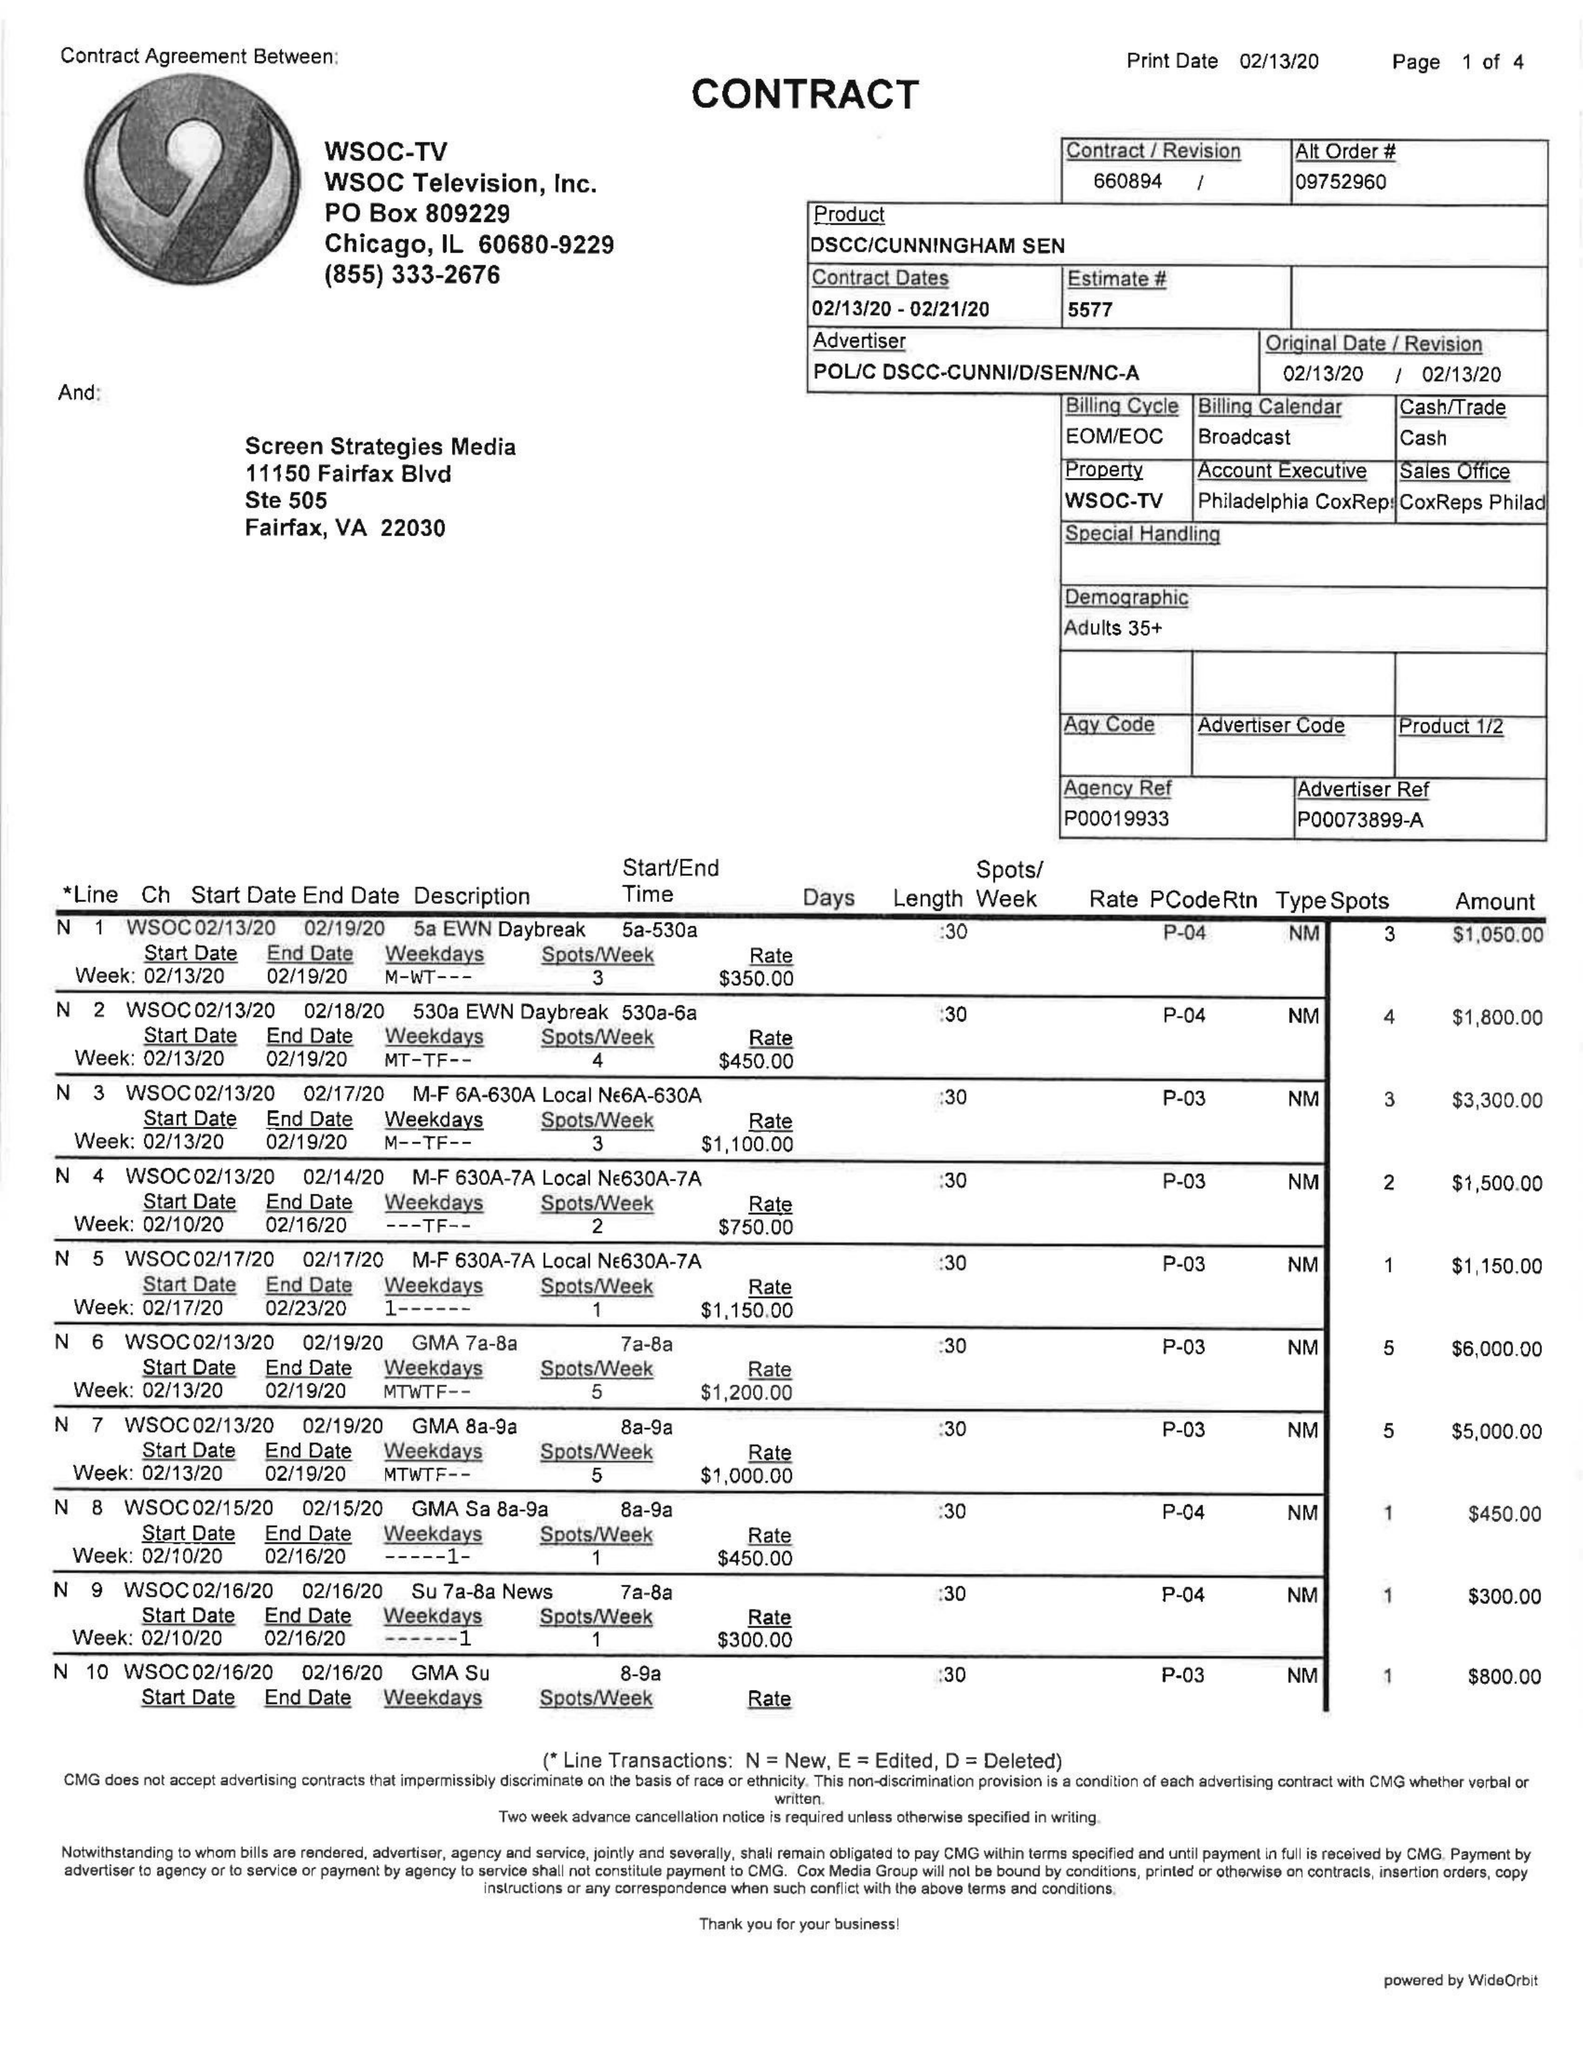What is the value for the gross_amount?
Answer the question using a single word or phrase. 70990.00 